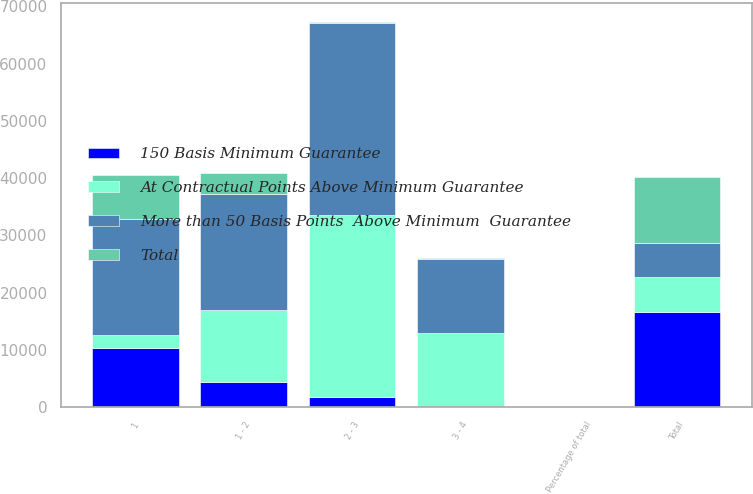Convert chart. <chart><loc_0><loc_0><loc_500><loc_500><stacked_bar_chart><ecel><fcel>1<fcel>1 - 2<fcel>2 - 3<fcel>3 - 4<fcel>Total<fcel>Percentage of total<nl><fcel>At Contractual Points Above Minimum Guarantee<fcel>2277<fcel>12450<fcel>31674<fcel>12922<fcel>6092.5<fcel>71<nl><fcel>Total<fcel>7732<fcel>3502<fcel>136<fcel>51<fcel>11421<fcel>12<nl><fcel>150 Basis Minimum Guarantee<fcel>10271<fcel>4453<fcel>1818<fcel>14<fcel>16565<fcel>17<nl><fcel>More than 50 Basis Points  Above Minimum  Guarantee<fcel>20280<fcel>20405<fcel>33628<fcel>12987<fcel>6092.5<fcel>100<nl></chart> 